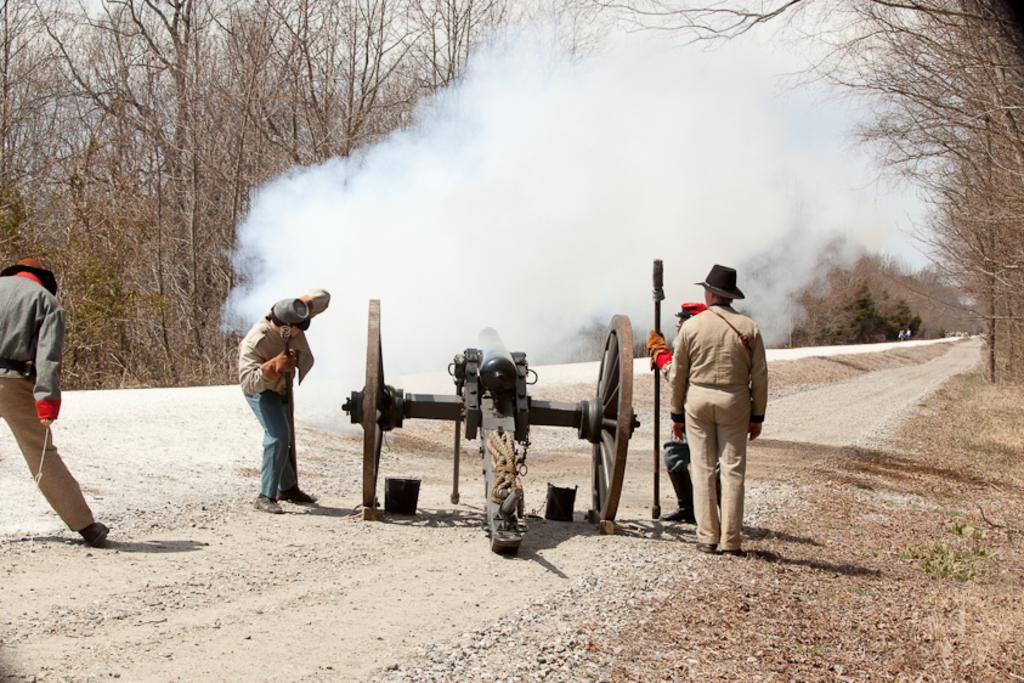What is the main object in the image? There is a cannon in the image. What are the people near the cannon doing? Some people are standing near the cannon. How are the people dressed? The people are wearing gloves and hats. What are the people holding in their hands? Some people are holding something in their hands. What can be seen in the background of the image? There is smoke visible in the background, and there are trees as well. What is the profit made by the feather in the image? There is no mention of profit or feathers in the image; it features a cannon and people standing near it. 